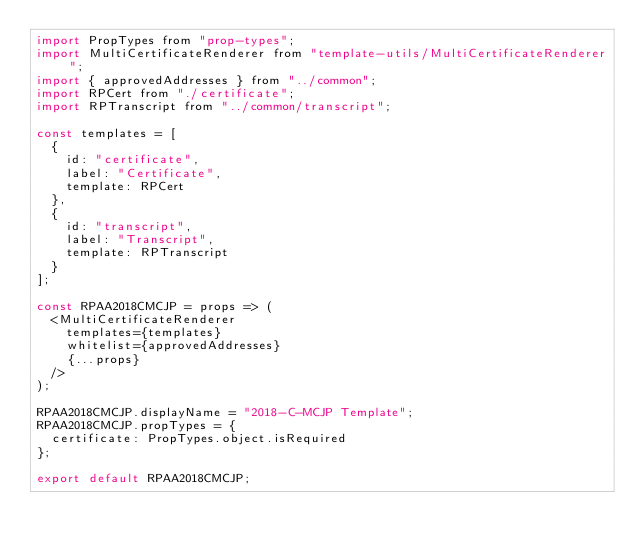Convert code to text. <code><loc_0><loc_0><loc_500><loc_500><_JavaScript_>import PropTypes from "prop-types";
import MultiCertificateRenderer from "template-utils/MultiCertificateRenderer";
import { approvedAddresses } from "../common";
import RPCert from "./certificate";
import RPTranscript from "../common/transcript";

const templates = [
  {
    id: "certificate",
    label: "Certificate",
    template: RPCert
  },
  {
    id: "transcript",
    label: "Transcript",
    template: RPTranscript
  }
];

const RPAA2018CMCJP = props => (
  <MultiCertificateRenderer
    templates={templates}
    whitelist={approvedAddresses}
    {...props}
  />
);

RPAA2018CMCJP.displayName = "2018-C-MCJP Template";
RPAA2018CMCJP.propTypes = {
  certificate: PropTypes.object.isRequired
};

export default RPAA2018CMCJP;
</code> 